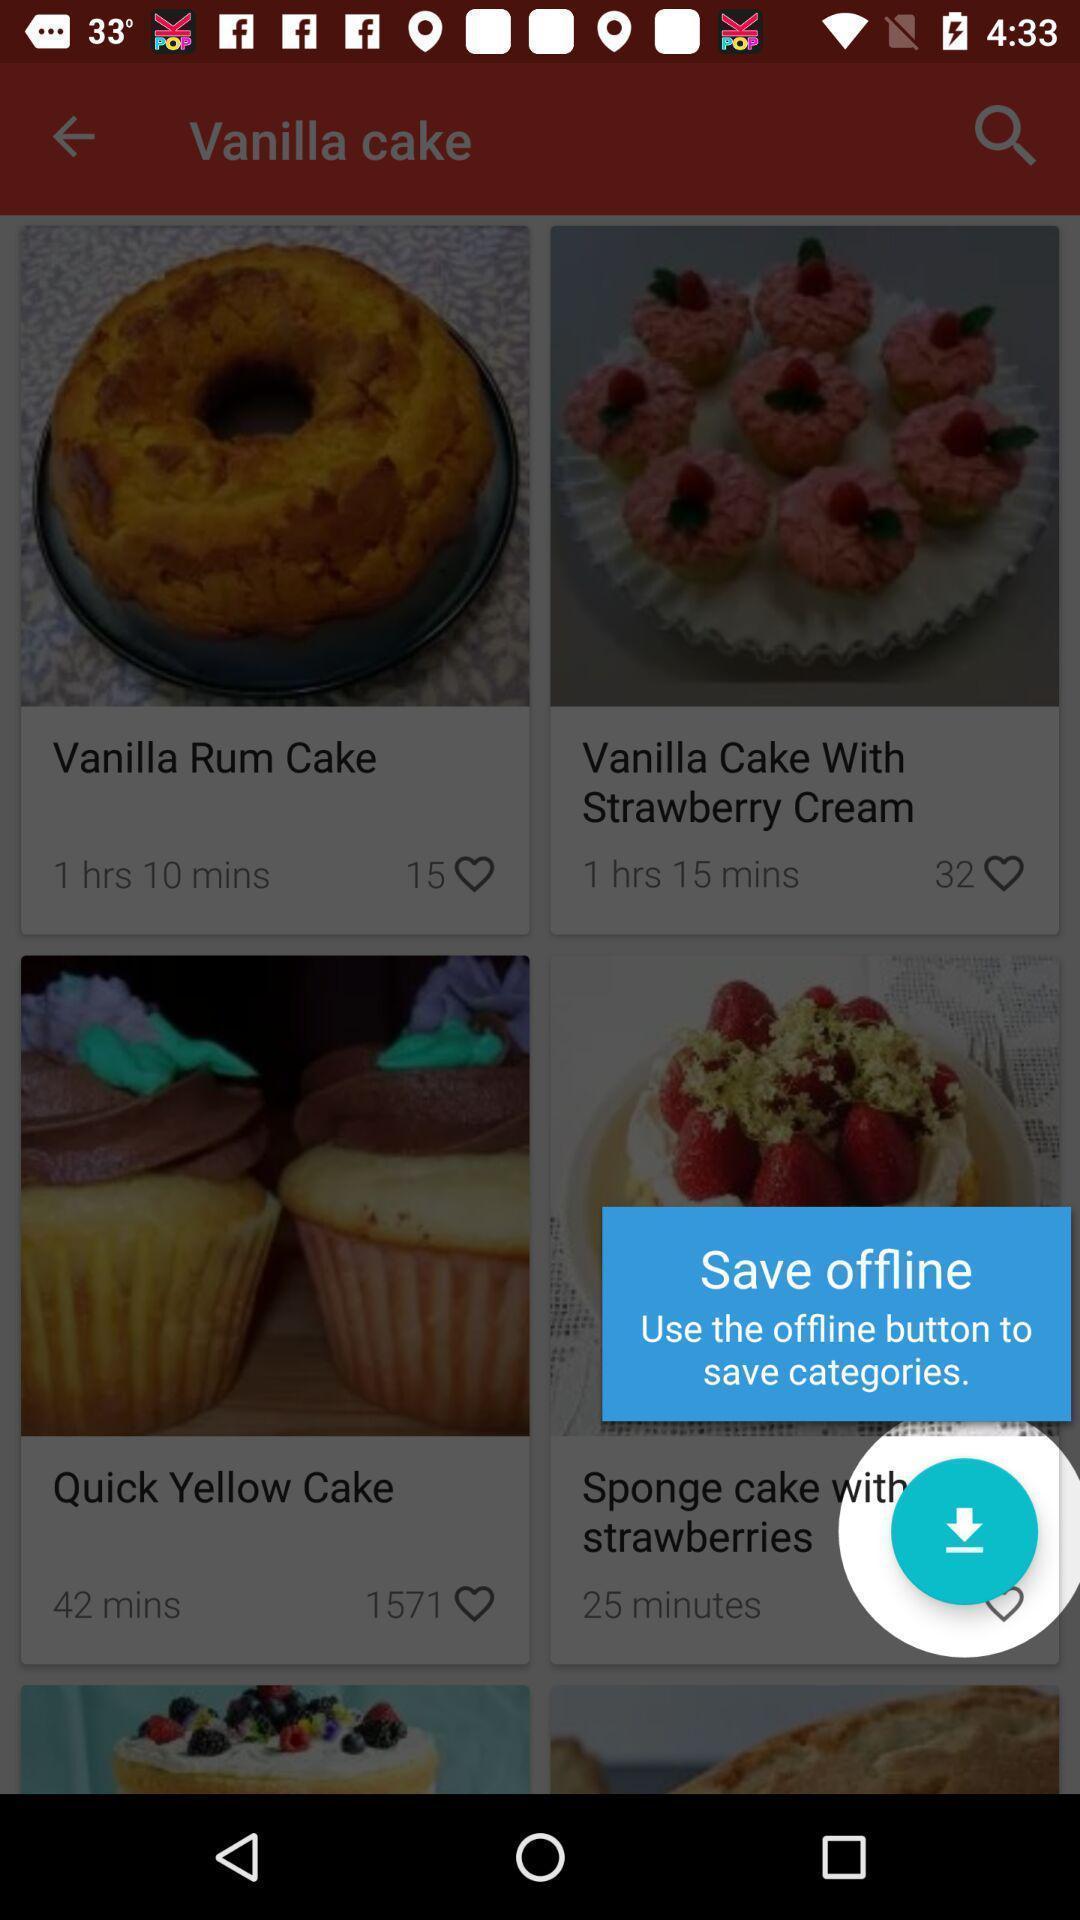Describe the visual elements of this screenshot. Pop-up displaying the save offline feature. 